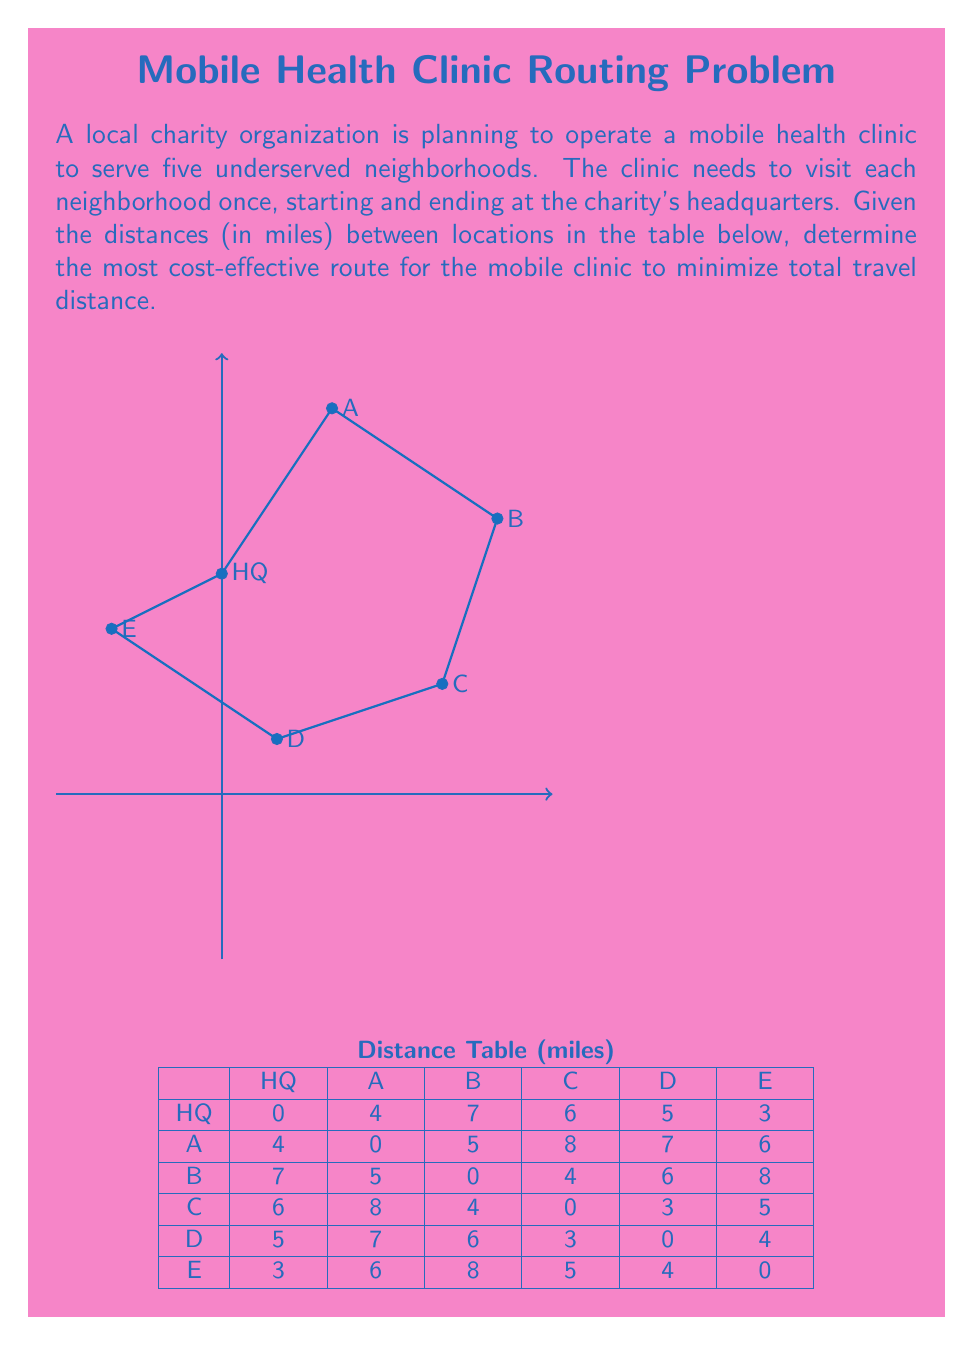What is the answer to this math problem? To find the most cost-effective route, we need to solve the Traveling Salesman Problem (TSP). Given the small number of locations, we can use a brute-force approach to find the optimal solution.

Step 1: List all possible routes.
There are $(5-1)! = 24$ possible routes, as the clinic must start and end at HQ, and visit each neighborhood once.

Step 2: Calculate the total distance for each route.
For example, let's calculate the distance for route HQ-A-B-C-D-E-HQ:
$4 + 5 + 4 + 3 + 4 + 3 = 23$ miles

Step 3: Compare all routes and find the shortest one.
After calculating all 24 routes, we find that the shortest route is:
HQ-E-D-C-B-A-HQ

Step 4: Calculate the total distance for the optimal route.
$3 + 4 + 3 + 4 + 5 + 4 = 23$ miles

This route minimizes the total travel distance, making it the most cost-effective for the mobile health clinic.
Answer: HQ-E-D-C-B-A-HQ, 23 miles 